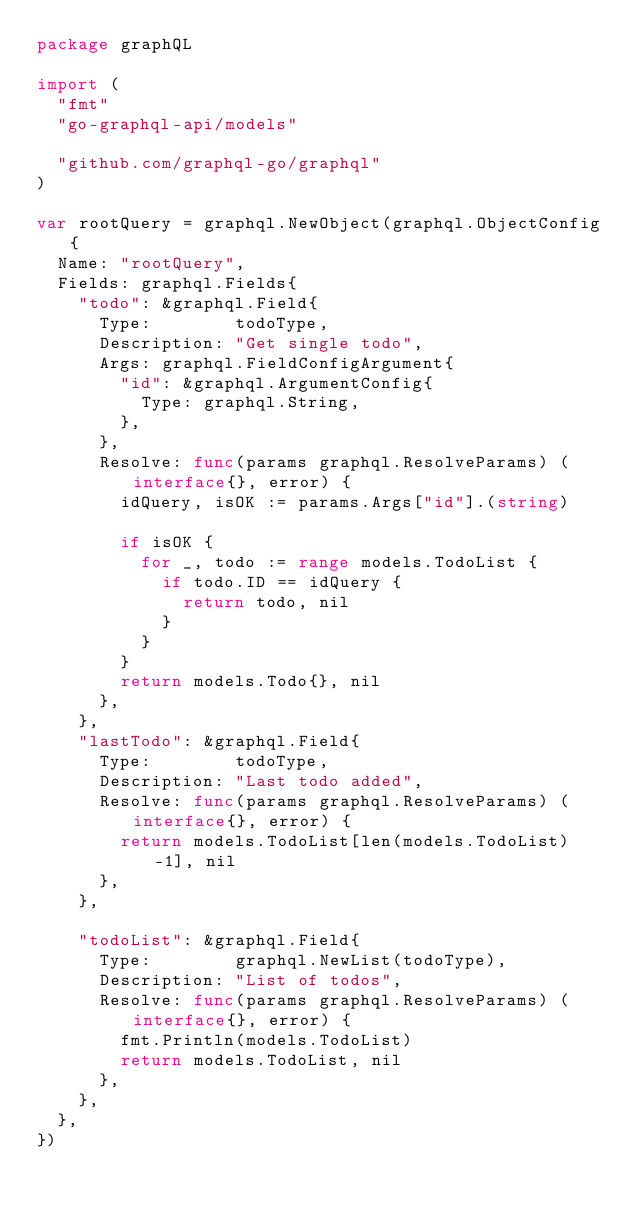<code> <loc_0><loc_0><loc_500><loc_500><_Go_>package graphQL

import (
	"fmt"
	"go-graphql-api/models"

	"github.com/graphql-go/graphql"
)

var rootQuery = graphql.NewObject(graphql.ObjectConfig{
	Name: "rootQuery",
	Fields: graphql.Fields{
		"todo": &graphql.Field{
			Type:        todoType,
			Description: "Get single todo",
			Args: graphql.FieldConfigArgument{
				"id": &graphql.ArgumentConfig{
					Type: graphql.String,
				},
			},
			Resolve: func(params graphql.ResolveParams) (interface{}, error) {
				idQuery, isOK := params.Args["id"].(string)

				if isOK {
					for _, todo := range models.TodoList {
						if todo.ID == idQuery {
							return todo, nil
						}
					}
				}
				return models.Todo{}, nil
			},
		},
		"lastTodo": &graphql.Field{
			Type:        todoType,
			Description: "Last todo added",
			Resolve: func(params graphql.ResolveParams) (interface{}, error) {
				return models.TodoList[len(models.TodoList)-1], nil
			},
		},

		"todoList": &graphql.Field{
			Type:        graphql.NewList(todoType),
			Description: "List of todos",
			Resolve: func(params graphql.ResolveParams) (interface{}, error) {
				fmt.Println(models.TodoList)
				return models.TodoList, nil
			},
		},
	},
})
</code> 